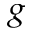<formula> <loc_0><loc_0><loc_500><loc_500>^ { g }</formula> 